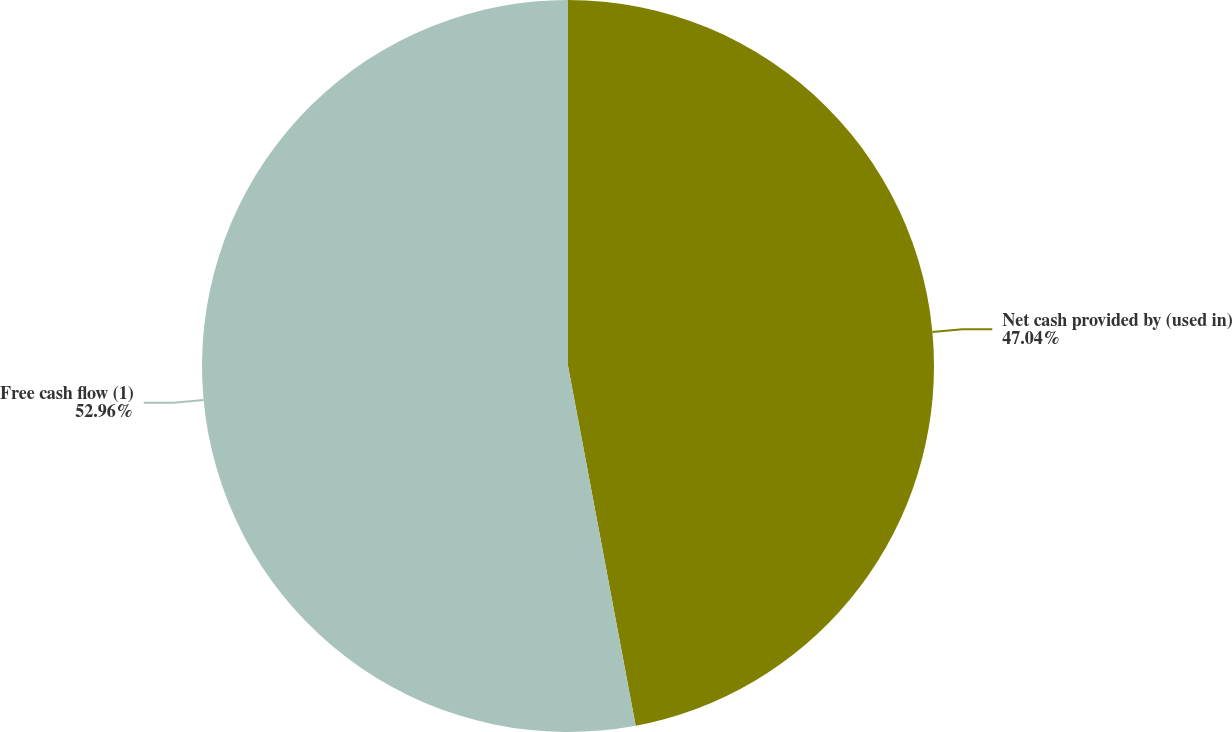<chart> <loc_0><loc_0><loc_500><loc_500><pie_chart><fcel>Net cash provided by (used in)<fcel>Free cash flow (1)<nl><fcel>47.04%<fcel>52.96%<nl></chart> 